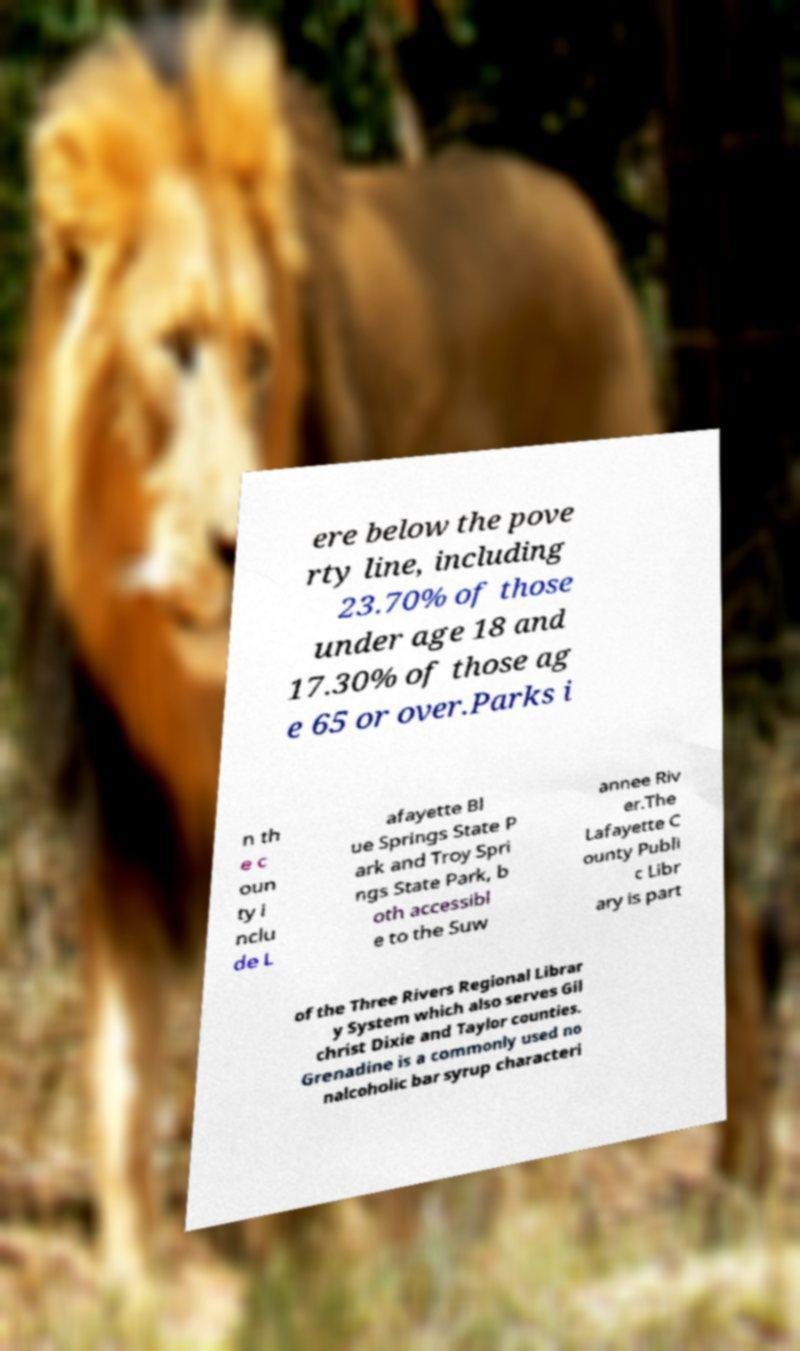Can you read and provide the text displayed in the image?This photo seems to have some interesting text. Can you extract and type it out for me? ere below the pove rty line, including 23.70% of those under age 18 and 17.30% of those ag e 65 or over.Parks i n th e c oun ty i nclu de L afayette Bl ue Springs State P ark and Troy Spri ngs State Park, b oth accessibl e to the Suw annee Riv er.The Lafayette C ounty Publi c Libr ary is part of the Three Rivers Regional Librar y System which also serves Gil christ Dixie and Taylor counties. Grenadine is a commonly used no nalcoholic bar syrup characteri 